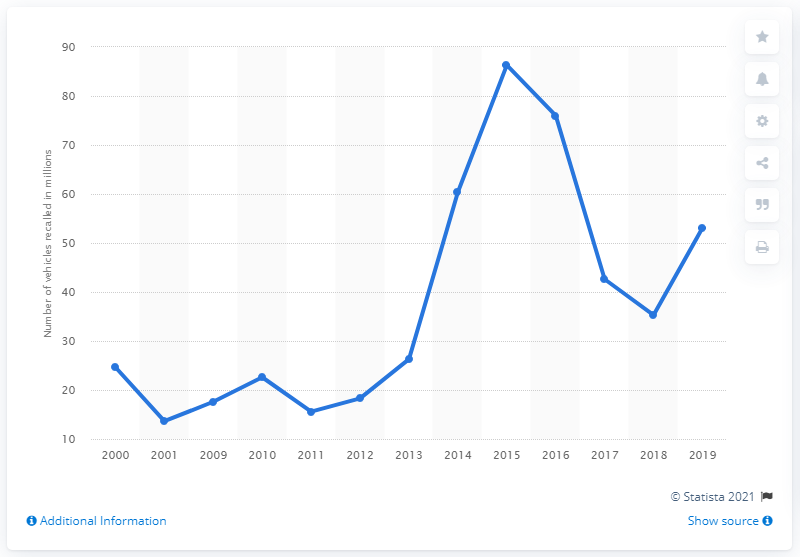Highlight a few significant elements in this photo. In the year 2016, Graco began its recalls. 